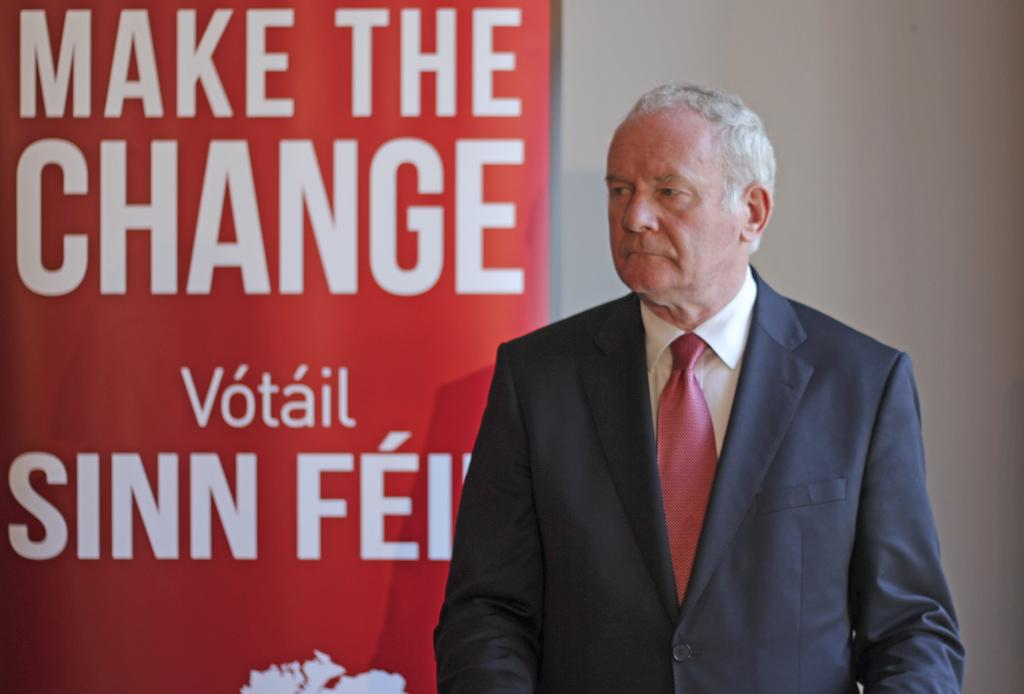What is the main subject of the image? There is a man standing in the image. What can be seen in the background of the image? There is a banner and a wall visible in the background of the image. What type of comfort can be seen being provided by the father in the image? There is no father present in the image, and therefore no comfort can be observed. Is there a mailbox visible in the image? There is no mailbox mentioned in the provided facts, so it cannot be determined if one is present in the image. 